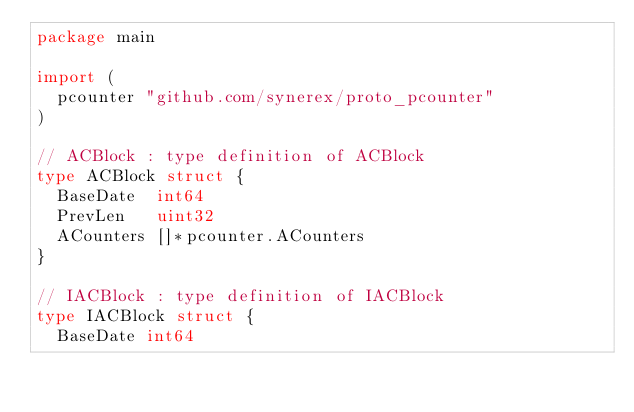Convert code to text. <code><loc_0><loc_0><loc_500><loc_500><_Go_>package main

import (
	pcounter "github.com/synerex/proto_pcounter"
)

// ACBlock : type definition of ACBlock
type ACBlock struct {
	BaseDate  int64
	PrevLen   uint32
	ACounters []*pcounter.ACounters
}

// IACBlock : type definition of IACBlock
type IACBlock struct {
	BaseDate int64</code> 